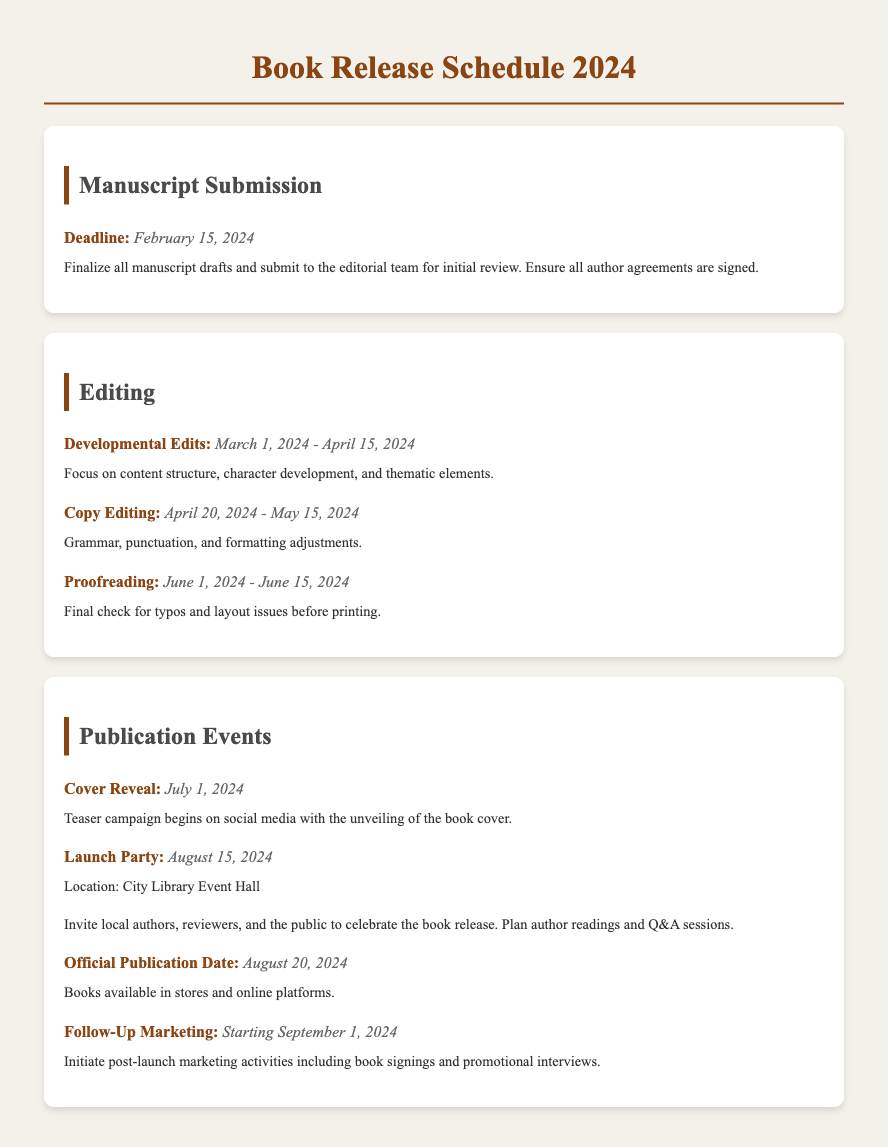What is the deadline for manuscript submission? The deadline for manuscript submission is provided in the "Manuscript Submission" section as February 15, 2024.
Answer: February 15, 2024 When do developmental edits start and end? The date range for developmental edits is in the "Editing" section, which states it begins on March 1, 2024, and ends on April 15, 2024.
Answer: March 1, 2024 - April 15, 2024 What event occurs on July 1, 2024? The event taking place on July 1, 2024, is detailed in the "Publication Events" section as the Cover Reveal.
Answer: Cover Reveal What is the location of the Launch Party? The document specifies the location of the Launch Party in the "Publication Events" section, which is the City Library Event Hall.
Answer: City Library Event Hall When does the official publication date occur? The document explicitly states the date of the official publication in the "Publication Events" section as August 20, 2024.
Answer: August 20, 2024 What activities start on September 1, 2024? The document outlines the activities that begin on September 1, 2024, in the "Publication Events" section as Follow-Up Marketing.
Answer: Follow-Up Marketing How long does proofreading last? The "Editing" section details the duration of proofreading as June 1, 2024 - June 15, 2024.
Answer: June 1, 2024 - June 15, 2024 What is the focus during the copy editing phase? The document indicates that the focus during copy editing is specifically on grammar, punctuation, and formatting adjustments.
Answer: Grammar, punctuation, and formatting adjustments 